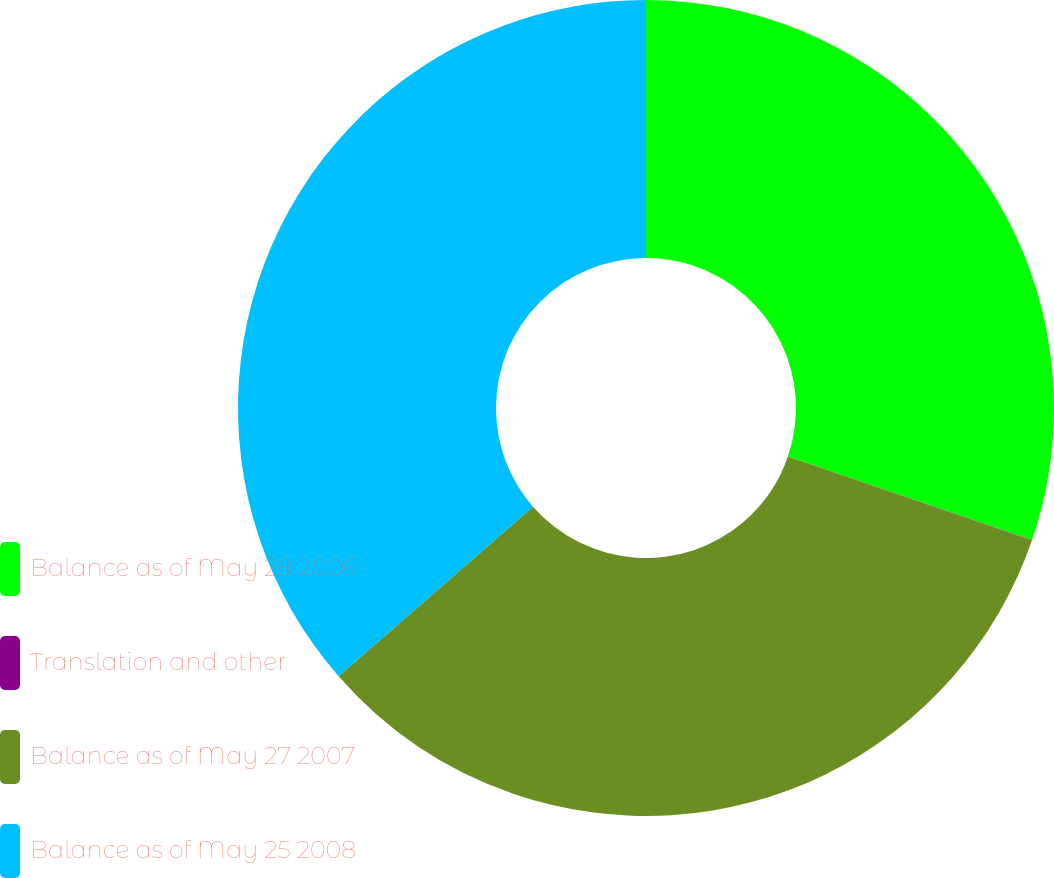Convert chart to OTSL. <chart><loc_0><loc_0><loc_500><loc_500><pie_chart><fcel>Balance as of May 28 2006<fcel>Translation and other<fcel>Balance as of May 27 2007<fcel>Balance as of May 25 2008<nl><fcel>30.24%<fcel>0.01%<fcel>33.33%<fcel>36.42%<nl></chart> 